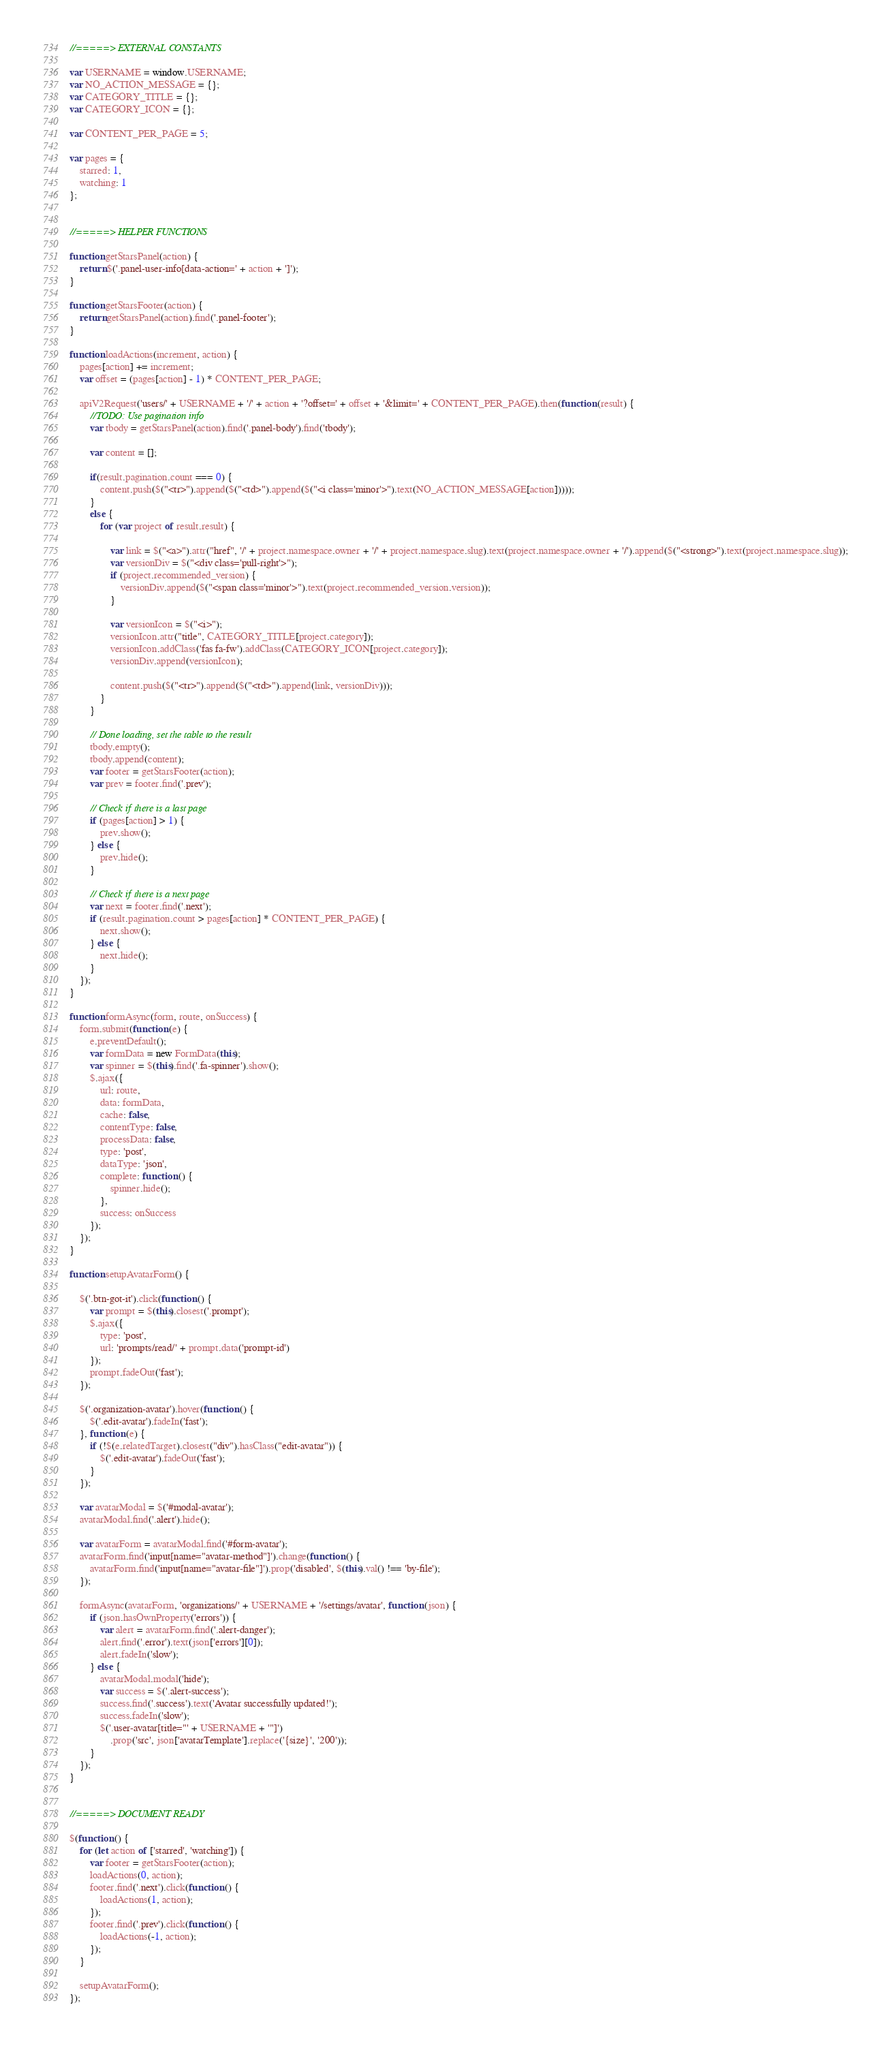<code> <loc_0><loc_0><loc_500><loc_500><_JavaScript_>//=====> EXTERNAL CONSTANTS

var USERNAME = window.USERNAME;
var NO_ACTION_MESSAGE = {};
var CATEGORY_TITLE = {};
var CATEGORY_ICON = {};

var CONTENT_PER_PAGE = 5;

var pages = {
    starred: 1,
    watching: 1
};


//=====> HELPER FUNCTIONS

function getStarsPanel(action) {
    return $('.panel-user-info[data-action=' + action + ']');
}

function getStarsFooter(action) {
    return getStarsPanel(action).find('.panel-footer');
}

function loadActions(increment, action) {
    pages[action] += increment;
    var offset = (pages[action] - 1) * CONTENT_PER_PAGE;

    apiV2Request('users/' + USERNAME + '/' + action + '?offset=' + offset + '&limit=' + CONTENT_PER_PAGE).then(function (result) {
        //TODO: Use pagination info
        var tbody = getStarsPanel(action).find('.panel-body').find('tbody');

        var content = [];

        if(result.pagination.count === 0) {
            content.push($("<tr>").append($("<td>").append($("<i class='minor'>").text(NO_ACTION_MESSAGE[action]))));
        }
        else {
            for (var project of result.result) {

                var link = $("<a>").attr("href", '/' + project.namespace.owner + '/' + project.namespace.slug).text(project.namespace.owner + '/').append($("<strong>").text(project.namespace.slug));
                var versionDiv = $("<div class='pull-right'>");
                if (project.recommended_version) {
                    versionDiv.append($("<span class='minor'>").text(project.recommended_version.version));
                }

                var versionIcon = $("<i>");
                versionIcon.attr("title", CATEGORY_TITLE[project.category]);
                versionIcon.addClass('fas fa-fw').addClass(CATEGORY_ICON[project.category]);
                versionDiv.append(versionIcon);

                content.push($("<tr>").append($("<td>").append(link, versionDiv)));
            }
        }

        // Done loading, set the table to the result
        tbody.empty();
        tbody.append(content);
        var footer = getStarsFooter(action);
        var prev = footer.find('.prev');

        // Check if there is a last page
        if (pages[action] > 1) {
            prev.show();
        } else {
            prev.hide();
        }

        // Check if there is a next page
        var next = footer.find('.next');
        if (result.pagination.count > pages[action] * CONTENT_PER_PAGE) {
            next.show();
        } else {
            next.hide();
        }
    });
}

function formAsync(form, route, onSuccess) {
    form.submit(function (e) {
        e.preventDefault();
        var formData = new FormData(this);
        var spinner = $(this).find('.fa-spinner').show();
        $.ajax({
            url: route,
            data: formData,
            cache: false,
            contentType: false,
            processData: false,
            type: 'post',
            dataType: 'json',
            complete: function () {
                spinner.hide();
            },
            success: onSuccess
        });
    });
}

function setupAvatarForm() {

    $('.btn-got-it').click(function () {
        var prompt = $(this).closest('.prompt');
        $.ajax({
            type: 'post',
            url: 'prompts/read/' + prompt.data('prompt-id')
        });
        prompt.fadeOut('fast');
    });

    $('.organization-avatar').hover(function () {
        $('.edit-avatar').fadeIn('fast');
    }, function (e) {
        if (!$(e.relatedTarget).closest("div").hasClass("edit-avatar")) {
            $('.edit-avatar').fadeOut('fast');
        }
    });

    var avatarModal = $('#modal-avatar');
    avatarModal.find('.alert').hide();

    var avatarForm = avatarModal.find('#form-avatar');
    avatarForm.find('input[name="avatar-method"]').change(function () {
        avatarForm.find('input[name="avatar-file"]').prop('disabled', $(this).val() !== 'by-file');
    });

    formAsync(avatarForm, 'organizations/' + USERNAME + '/settings/avatar', function (json) {
        if (json.hasOwnProperty('errors')) {
            var alert = avatarForm.find('.alert-danger');
            alert.find('.error').text(json['errors'][0]);
            alert.fadeIn('slow');
        } else {
            avatarModal.modal('hide');
            var success = $('.alert-success');
            success.find('.success').text('Avatar successfully updated!');
            success.fadeIn('slow');
            $('.user-avatar[title="' + USERNAME + '"]')
                .prop('src', json['avatarTemplate'].replace('{size}', '200'));
        }
    });
}


//=====> DOCUMENT READY

$(function () {
    for (let action of ['starred', 'watching']) {
        var footer = getStarsFooter(action);
        loadActions(0, action);
        footer.find('.next').click(function () {
            loadActions(1, action);
        });
        footer.find('.prev').click(function () {
            loadActions(-1, action);
        });
    }

    setupAvatarForm();
});
</code> 